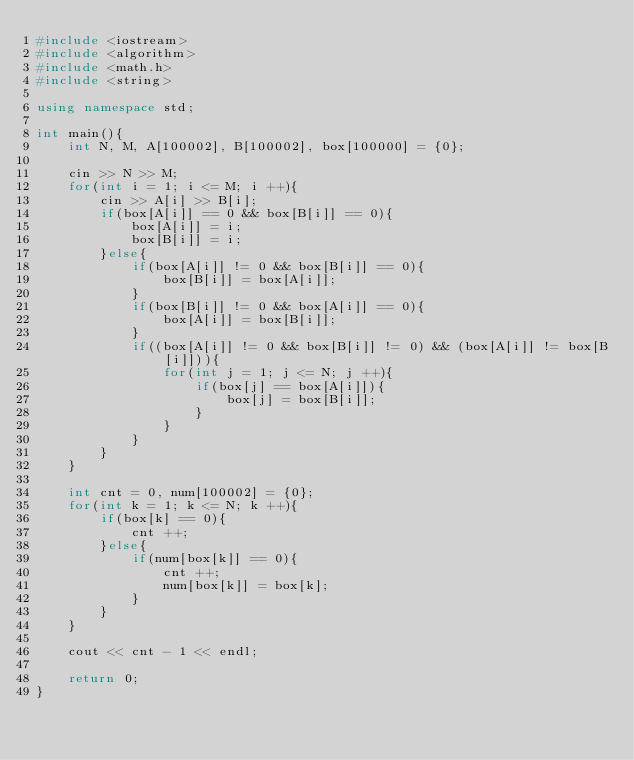<code> <loc_0><loc_0><loc_500><loc_500><_C++_>#include <iostream>
#include <algorithm>
#include <math.h>
#include <string>

using namespace std;

int main(){
    int N, M, A[100002], B[100002], box[100000] = {0};

    cin >> N >> M;
    for(int i = 1; i <= M; i ++){
        cin >> A[i] >> B[i];
        if(box[A[i]] == 0 && box[B[i]] == 0){
            box[A[i]] = i;
            box[B[i]] = i;
        }else{
            if(box[A[i]] != 0 && box[B[i]] == 0){
                box[B[i]] = box[A[i]];
            }
            if(box[B[i]] != 0 && box[A[i]] == 0){
                box[A[i]] = box[B[i]];
            }
            if((box[A[i]] != 0 && box[B[i]] != 0) && (box[A[i]] != box[B[i]])){
                for(int j = 1; j <= N; j ++){
                    if(box[j] == box[A[i]]){
                        box[j] = box[B[i]];
                    }
                }
            }
        }
    }
    
    int cnt = 0, num[100002] = {0};
    for(int k = 1; k <= N; k ++){
        if(box[k] == 0){
            cnt ++;
        }else{
            if(num[box[k]] == 0){
                cnt ++;
                num[box[k]] = box[k];
            }
        }
    }

    cout << cnt - 1 << endl;

    return 0;
}
</code> 